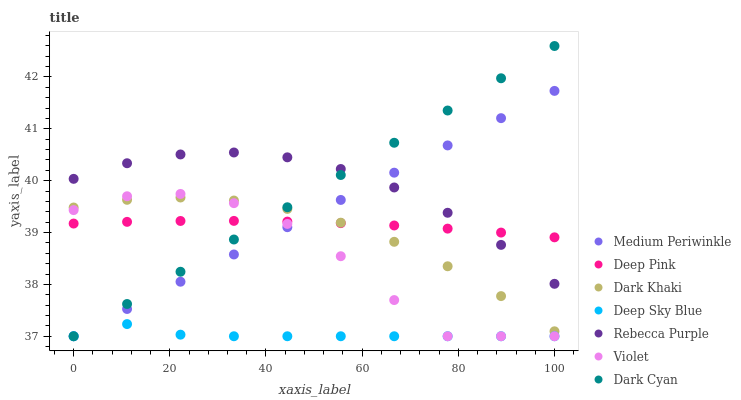Does Deep Sky Blue have the minimum area under the curve?
Answer yes or no. Yes. Does Rebecca Purple have the maximum area under the curve?
Answer yes or no. Yes. Does Medium Periwinkle have the minimum area under the curve?
Answer yes or no. No. Does Medium Periwinkle have the maximum area under the curve?
Answer yes or no. No. Is Medium Periwinkle the smoothest?
Answer yes or no. Yes. Is Violet the roughest?
Answer yes or no. Yes. Is Dark Khaki the smoothest?
Answer yes or no. No. Is Dark Khaki the roughest?
Answer yes or no. No. Does Medium Periwinkle have the lowest value?
Answer yes or no. Yes. Does Dark Khaki have the lowest value?
Answer yes or no. No. Does Dark Cyan have the highest value?
Answer yes or no. Yes. Does Medium Periwinkle have the highest value?
Answer yes or no. No. Is Deep Sky Blue less than Rebecca Purple?
Answer yes or no. Yes. Is Rebecca Purple greater than Dark Khaki?
Answer yes or no. Yes. Does Deep Sky Blue intersect Medium Periwinkle?
Answer yes or no. Yes. Is Deep Sky Blue less than Medium Periwinkle?
Answer yes or no. No. Is Deep Sky Blue greater than Medium Periwinkle?
Answer yes or no. No. Does Deep Sky Blue intersect Rebecca Purple?
Answer yes or no. No. 